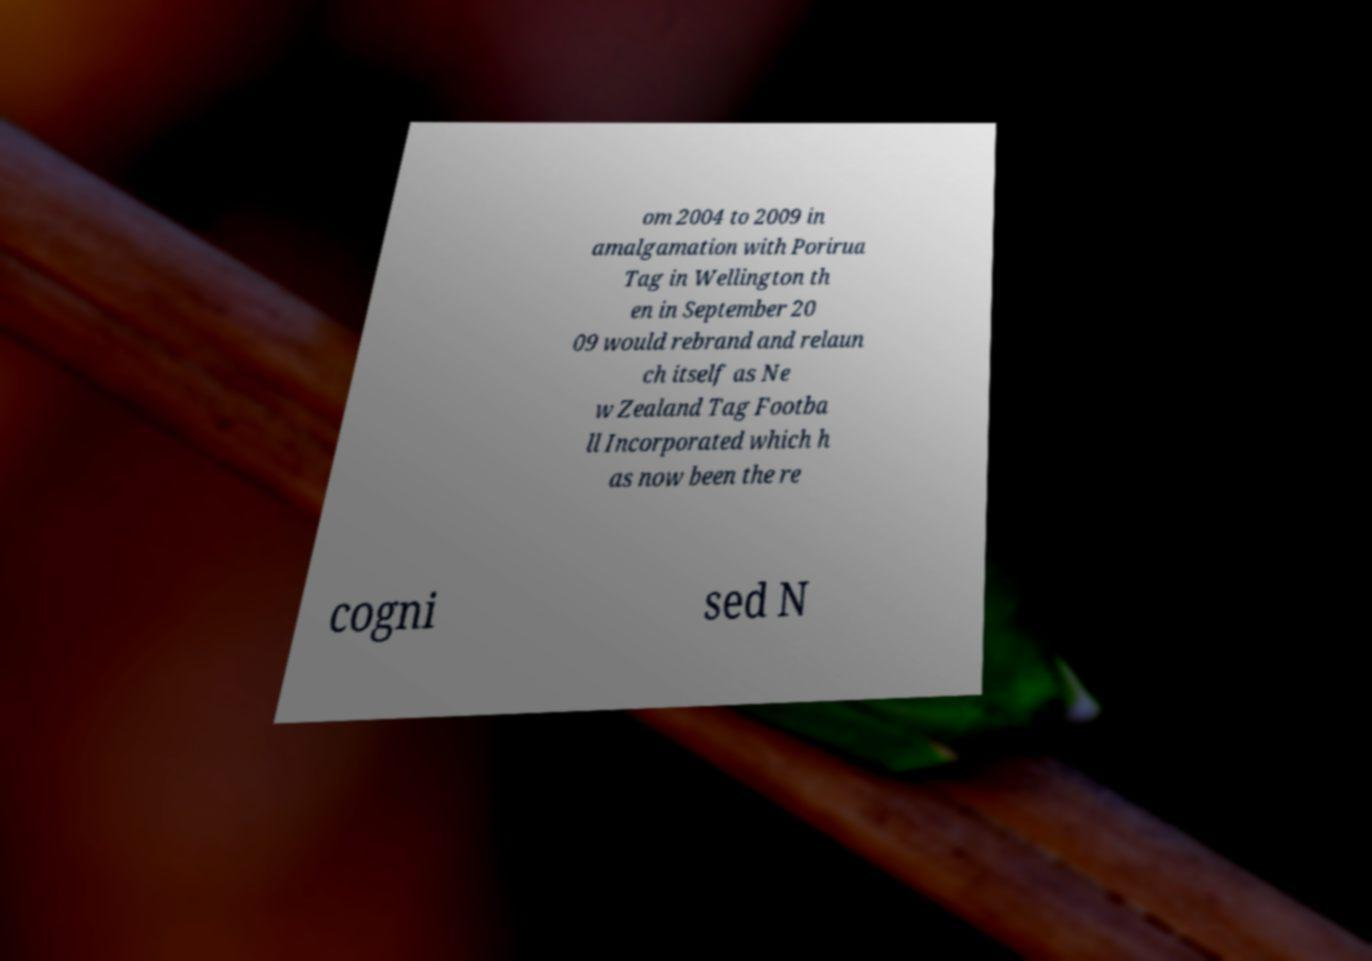Could you extract and type out the text from this image? om 2004 to 2009 in amalgamation with Porirua Tag in Wellington th en in September 20 09 would rebrand and relaun ch itself as Ne w Zealand Tag Footba ll Incorporated which h as now been the re cogni sed N 